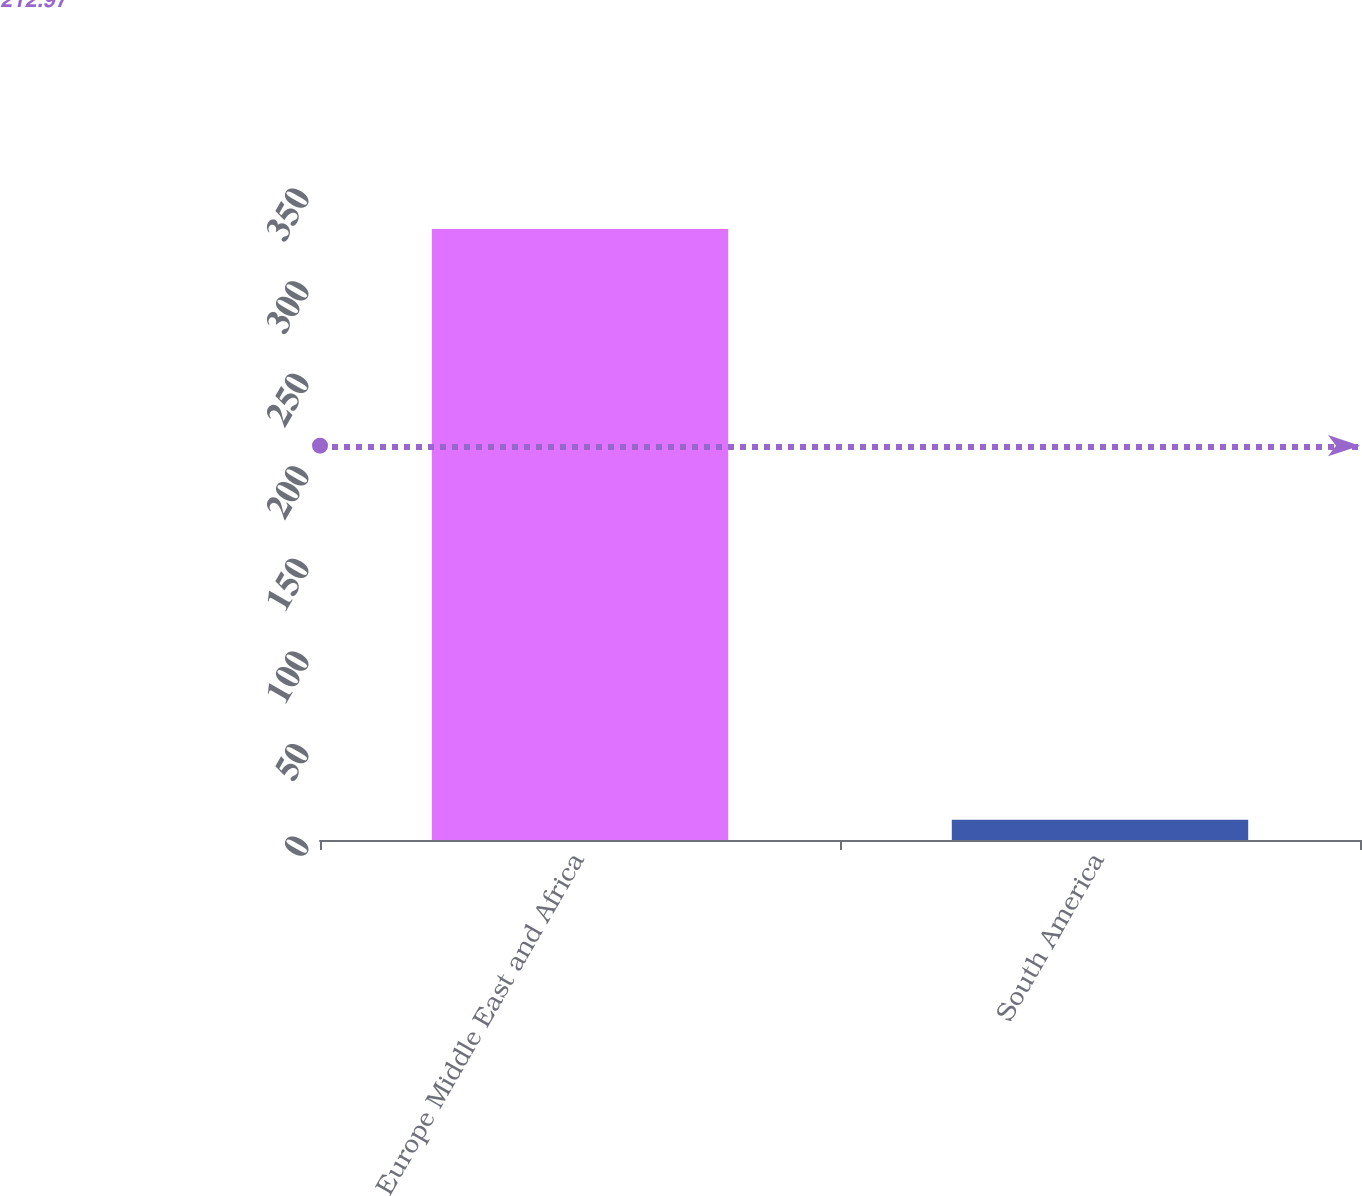Convert chart. <chart><loc_0><loc_0><loc_500><loc_500><bar_chart><fcel>Europe Middle East and Africa<fcel>South America<nl><fcel>330<fcel>11<nl></chart> 